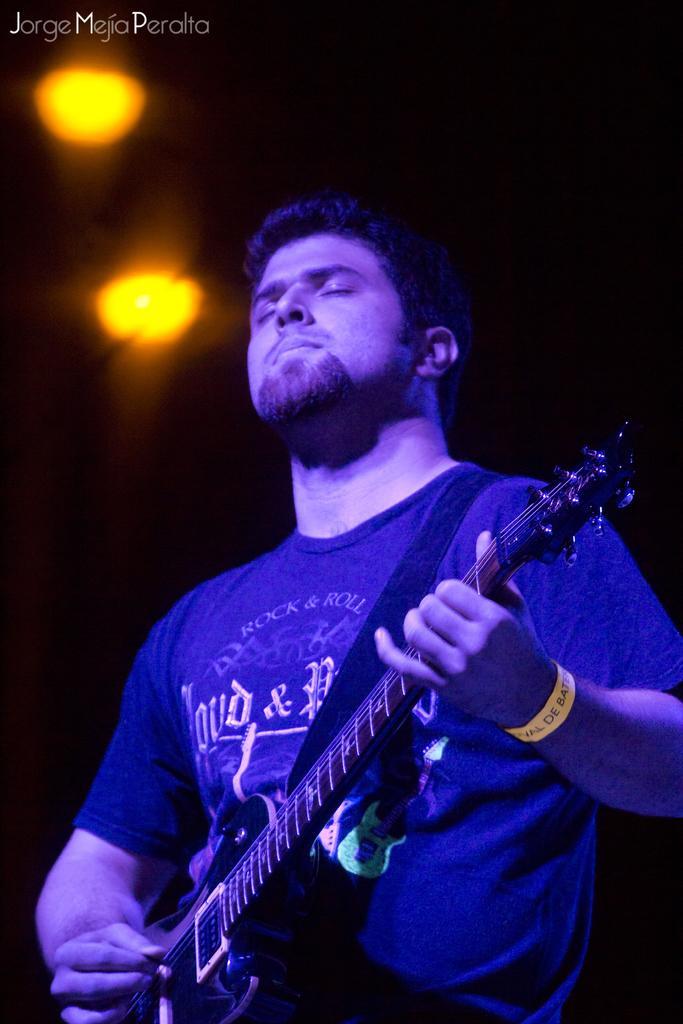Can you describe this image briefly? This picture is clicked in a musical concert. The man in blue t-shirt is holding guitar in his hands and playing it and on top of him, we see two lights which are yellow in color. 